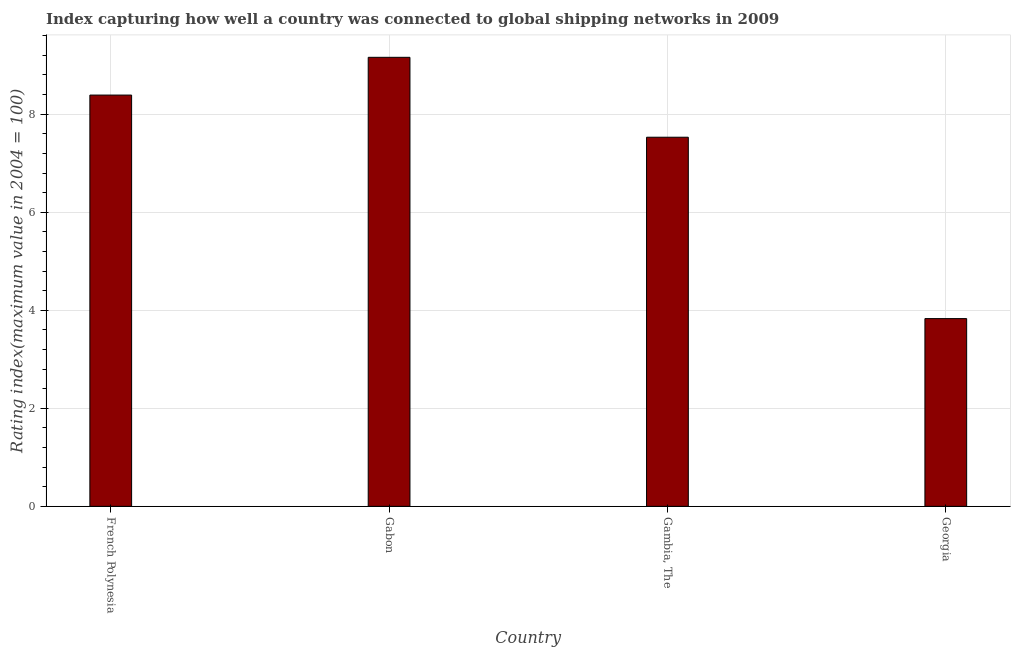Does the graph contain any zero values?
Provide a succinct answer. No. What is the title of the graph?
Ensure brevity in your answer.  Index capturing how well a country was connected to global shipping networks in 2009. What is the label or title of the Y-axis?
Offer a very short reply. Rating index(maximum value in 2004 = 100). What is the liner shipping connectivity index in Georgia?
Your answer should be very brief. 3.83. Across all countries, what is the maximum liner shipping connectivity index?
Ensure brevity in your answer.  9.16. Across all countries, what is the minimum liner shipping connectivity index?
Your answer should be compact. 3.83. In which country was the liner shipping connectivity index maximum?
Your answer should be very brief. Gabon. In which country was the liner shipping connectivity index minimum?
Your response must be concise. Georgia. What is the sum of the liner shipping connectivity index?
Provide a short and direct response. 28.91. What is the average liner shipping connectivity index per country?
Offer a very short reply. 7.23. What is the median liner shipping connectivity index?
Offer a very short reply. 7.96. What is the ratio of the liner shipping connectivity index in French Polynesia to that in Gabon?
Your answer should be very brief. 0.92. Is the difference between the liner shipping connectivity index in French Polynesia and Georgia greater than the difference between any two countries?
Make the answer very short. No. What is the difference between the highest and the second highest liner shipping connectivity index?
Keep it short and to the point. 0.77. What is the difference between the highest and the lowest liner shipping connectivity index?
Your response must be concise. 5.33. In how many countries, is the liner shipping connectivity index greater than the average liner shipping connectivity index taken over all countries?
Provide a short and direct response. 3. How many bars are there?
Your answer should be compact. 4. How many countries are there in the graph?
Give a very brief answer. 4. Are the values on the major ticks of Y-axis written in scientific E-notation?
Give a very brief answer. No. What is the Rating index(maximum value in 2004 = 100) in French Polynesia?
Your response must be concise. 8.39. What is the Rating index(maximum value in 2004 = 100) of Gabon?
Make the answer very short. 9.16. What is the Rating index(maximum value in 2004 = 100) in Gambia, The?
Your response must be concise. 7.53. What is the Rating index(maximum value in 2004 = 100) in Georgia?
Your answer should be very brief. 3.83. What is the difference between the Rating index(maximum value in 2004 = 100) in French Polynesia and Gabon?
Provide a short and direct response. -0.77. What is the difference between the Rating index(maximum value in 2004 = 100) in French Polynesia and Gambia, The?
Your response must be concise. 0.86. What is the difference between the Rating index(maximum value in 2004 = 100) in French Polynesia and Georgia?
Offer a terse response. 4.56. What is the difference between the Rating index(maximum value in 2004 = 100) in Gabon and Gambia, The?
Provide a succinct answer. 1.63. What is the difference between the Rating index(maximum value in 2004 = 100) in Gabon and Georgia?
Give a very brief answer. 5.33. What is the difference between the Rating index(maximum value in 2004 = 100) in Gambia, The and Georgia?
Offer a very short reply. 3.7. What is the ratio of the Rating index(maximum value in 2004 = 100) in French Polynesia to that in Gabon?
Offer a terse response. 0.92. What is the ratio of the Rating index(maximum value in 2004 = 100) in French Polynesia to that in Gambia, The?
Provide a short and direct response. 1.11. What is the ratio of the Rating index(maximum value in 2004 = 100) in French Polynesia to that in Georgia?
Offer a very short reply. 2.19. What is the ratio of the Rating index(maximum value in 2004 = 100) in Gabon to that in Gambia, The?
Make the answer very short. 1.22. What is the ratio of the Rating index(maximum value in 2004 = 100) in Gabon to that in Georgia?
Your answer should be very brief. 2.39. What is the ratio of the Rating index(maximum value in 2004 = 100) in Gambia, The to that in Georgia?
Make the answer very short. 1.97. 